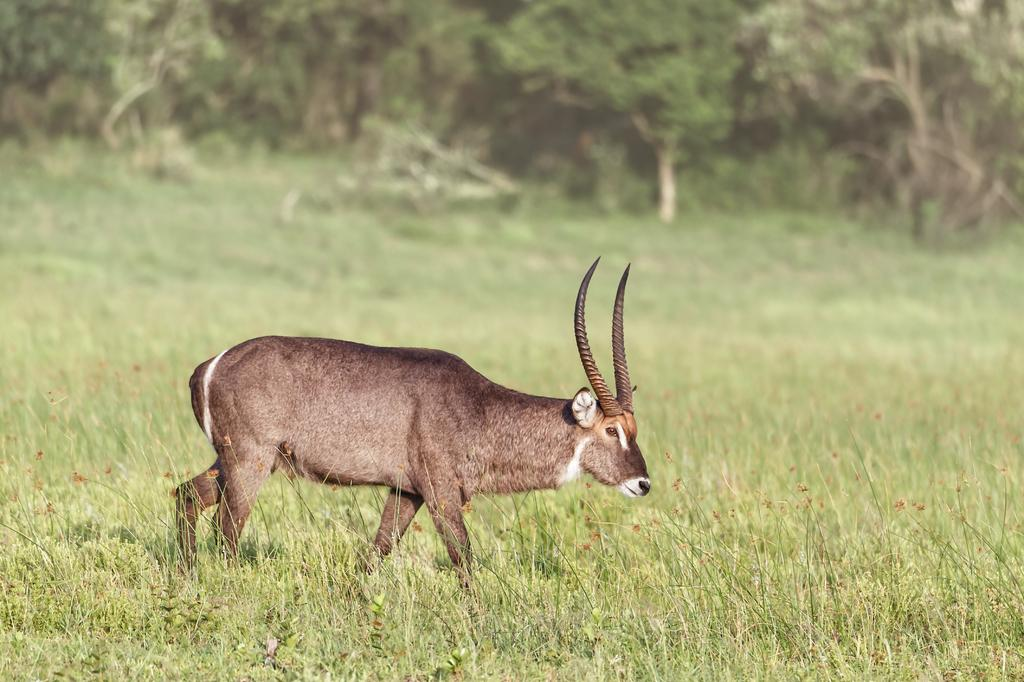What type of animal can be seen in the image? There is an animal in the image, but its specific type cannot be determined from the provided facts. What color is the animal in the image? The animal is brown in color. What type of vegetation is present in the image? There is grass in the image, and it is green in color. Are there any other plants visible in the image? Yes, there are trees in the image, and they are green in color. What type of glue is being used by the actor in the car in the image? There is no car, actor, or glue present in the image. The image features an animal and vegetation, as described in the conversation. 